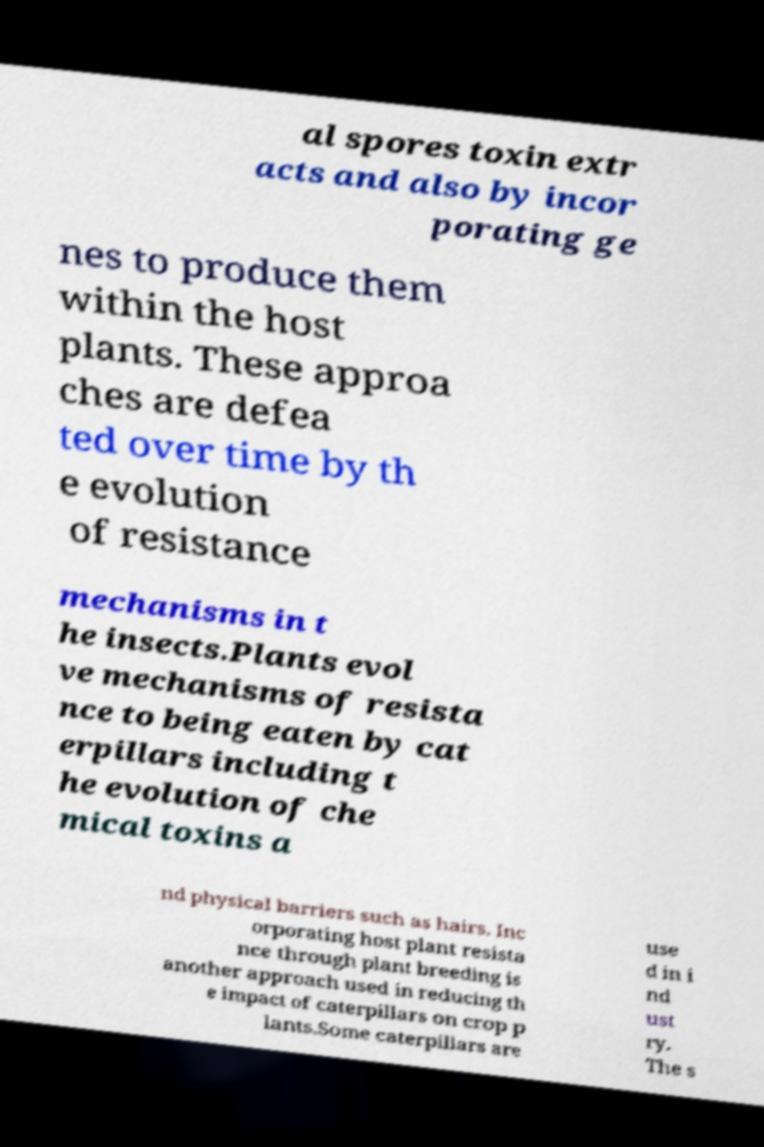Can you accurately transcribe the text from the provided image for me? al spores toxin extr acts and also by incor porating ge nes to produce them within the host plants. These approa ches are defea ted over time by th e evolution of resistance mechanisms in t he insects.Plants evol ve mechanisms of resista nce to being eaten by cat erpillars including t he evolution of che mical toxins a nd physical barriers such as hairs. Inc orporating host plant resista nce through plant breeding is another approach used in reducing th e impact of caterpillars on crop p lants.Some caterpillars are use d in i nd ust ry. The s 